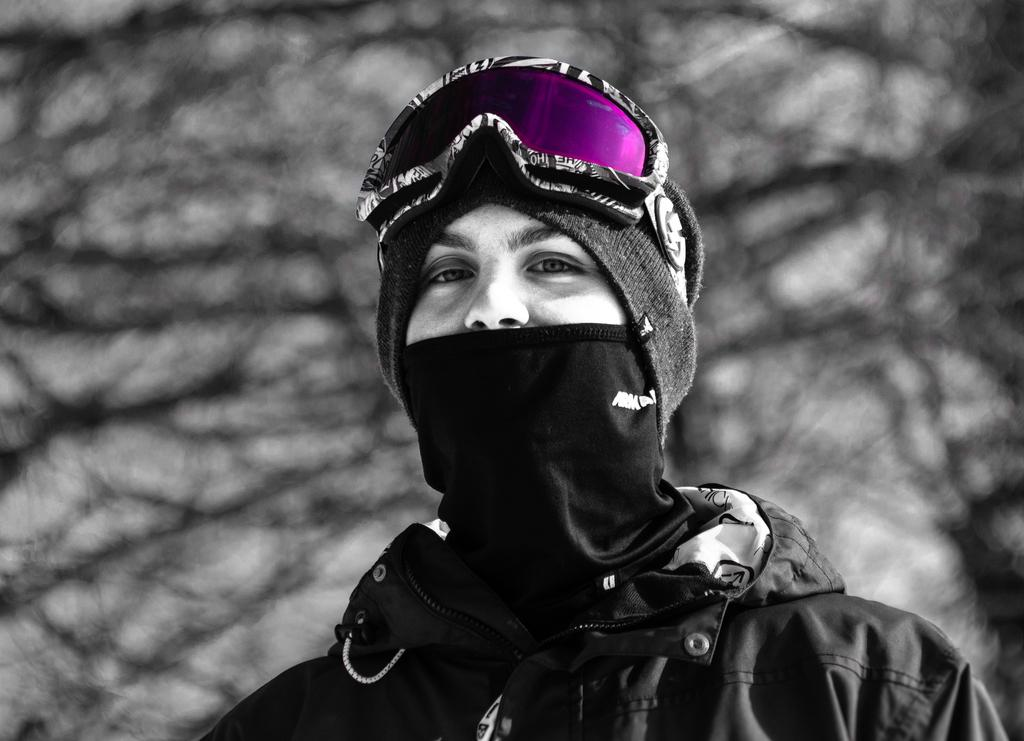What is the main subject of the image? There is a person in the center of the image. What protective gear is the person wearing? The person is wearing goggles. What type of clothing is the person wearing? The person is wearing a hat and a coat. What can be seen in the background of the image? There are twigs in the background of the image. What type of seed is the goose eating in the image? There is no goose or seed present in the image; it features a person wearing goggles, a hat, and a coat, with twigs in the background. 